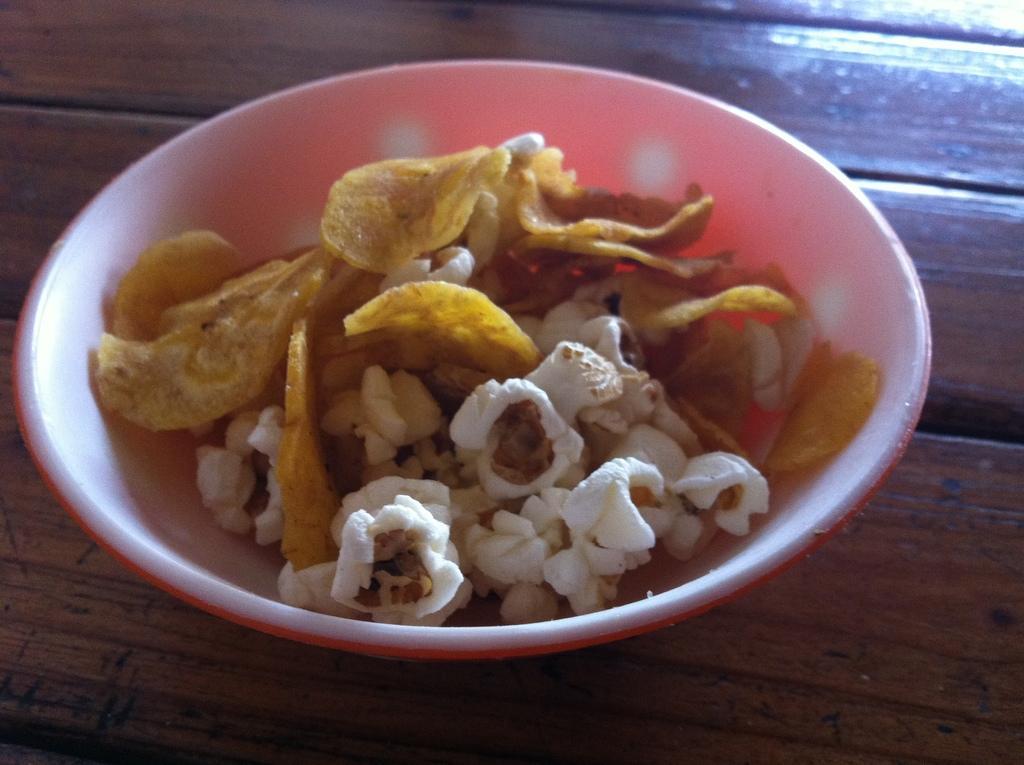In one or two sentences, can you explain what this image depicts? In this picture we can see a bowl, in this bowl we can see food items and this bowl is placed on a platform. 